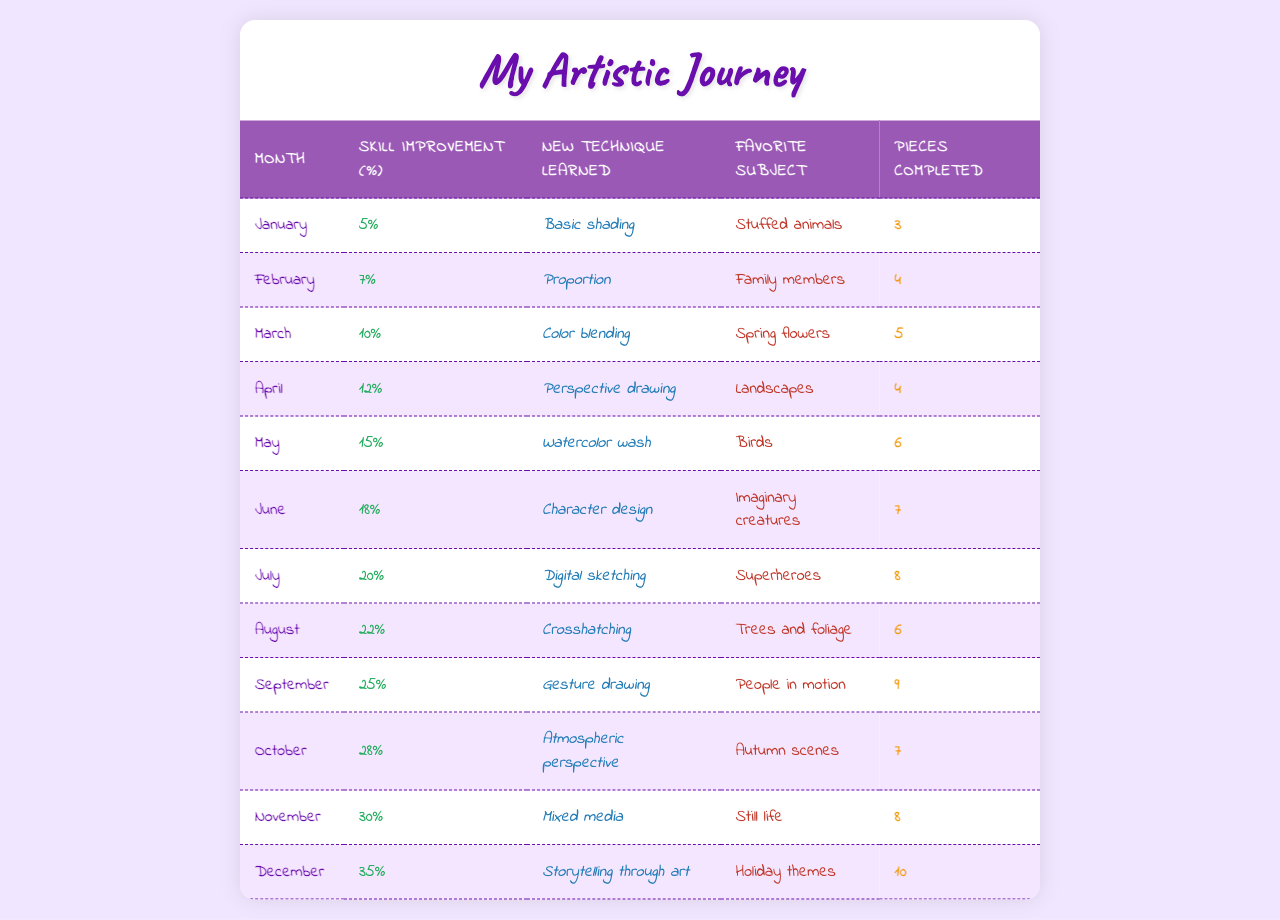What was the skill improvement percentage in May? In May, the table states a skill improvement of 15%.
Answer: 15% Which new technique was learned in June? The table indicates that the new technique learned in June was "Character design."
Answer: Character design How many pieces were completed in October? According to the table, 7 pieces were completed in October.
Answer: 7 What is the favorite subject for the month of March? The table shows that the favorite subject in March was "Spring flowers."
Answer: Spring flowers In which month did the artist learn digital sketching? The artist learned digital sketching in July, as indicated in the table.
Answer: July How many pieces in total were completed from January to April? To find the total pieces, sum the completed pieces from January (3), February (4), March (5), and April (4); that gives 3 + 4 + 5 + 4 = 16.
Answer: 16 Was there an increase in skill improvement from September to October? Yes, the skill improvement increased from 25% in September to 28% in October.
Answer: Yes What was the average skill improvement percentage from January to December? To find the average, sum the skill improvements (5 + 7 + 10 + 12 + 15 + 18 + 20 + 22 + 25 + 28 + 30 + 35 =  282) and divide by 12 months; 282 / 12 = 23.5%.
Answer: 23.5% If the artist completed 10 pieces in December, how does that compare with the average completed pieces from January to December? The total pieces completed from January (3) to December (10) are 3 + 4 + 5 + 4 + 6 + 7 + 8 + 6 + 9 + 7 + 8 + 10 = 66. The average is 66 / 12 = 5.5. Since 10 is greater than 5.5, the artist completed above average in December.
Answer: Above average In which month did the percentage improvement first exceed 20%? The percentage improvement first exceeded 20% in July, where it reached 20% exactly.
Answer: July 